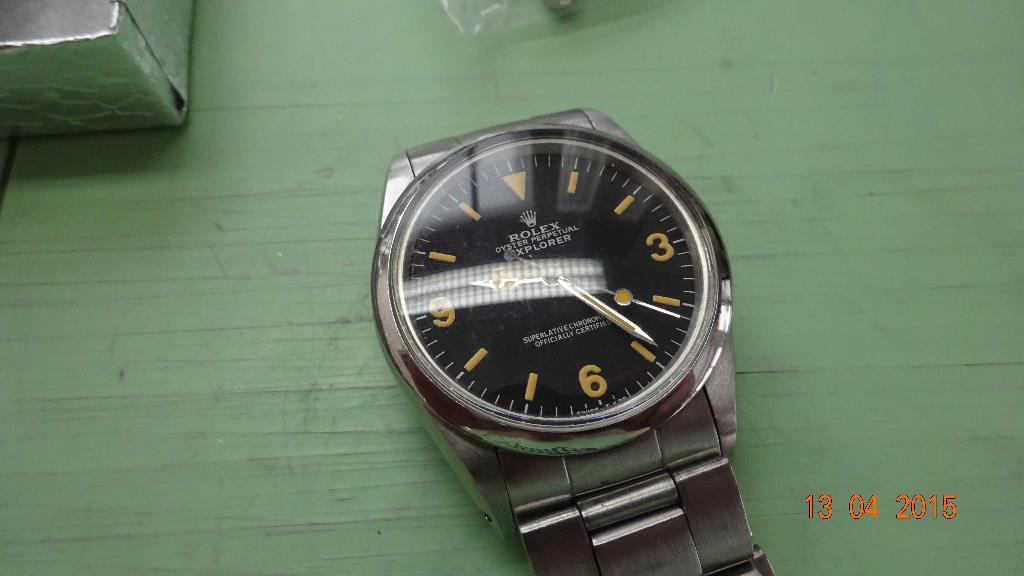<image>
Present a compact description of the photo's key features. Black and gray watch with the word ROLEx on the face on a green top. 